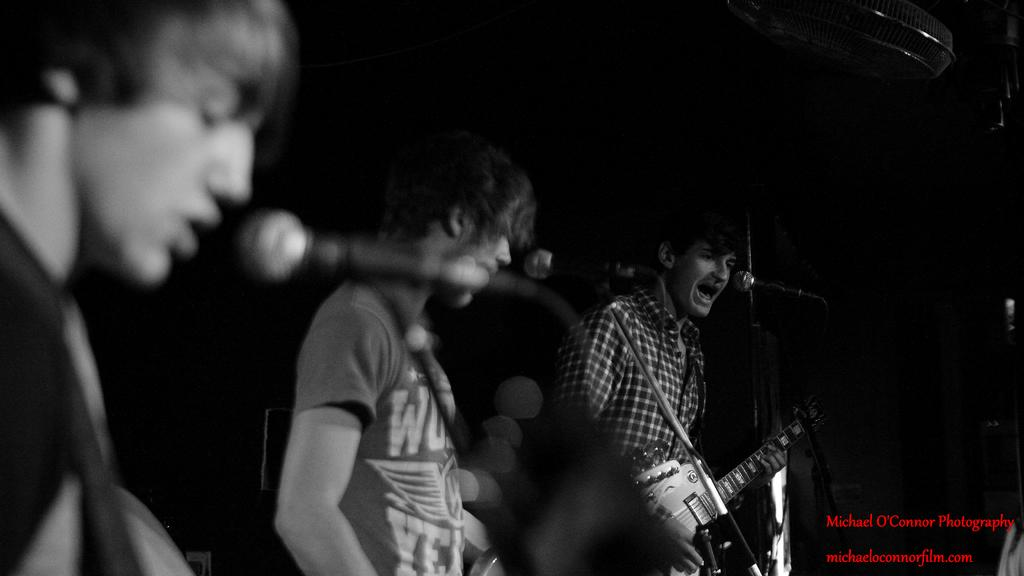How many people are in the image? There are three persons in the image. What are the persons holding in the image? Each person is carrying a guitar. What activity are the persons engaged in? The persons are singing in front of a microphone. Can you describe any additional objects in the image? There is a fan in the top right corner of the image. What degree does the person holding the toothbrush have in the image? There is no toothbrush or mention of a degree in the image; it features three persons playing guitars and singing. 